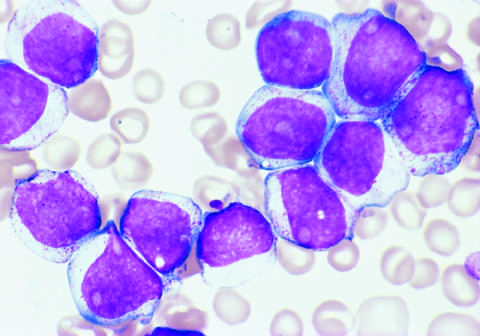s the glomerulus result for the aml shown in the figure?
Answer the question using a single word or phrase. No 